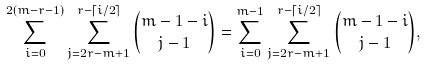Convert formula to latex. <formula><loc_0><loc_0><loc_500><loc_500>\sum _ { i = 0 } ^ { 2 ( m - r - 1 ) } \sum _ { j = 2 r - m + 1 } ^ { r - \lceil { i / 2 } \rceil } \binom { m - 1 - i } { j - 1 } = \sum _ { i = 0 } ^ { m - 1 } \sum _ { j = 2 r - m + 1 } ^ { r - \lceil { i / 2 } \rceil } \binom { m - 1 - i } { j - 1 } ,</formula> 